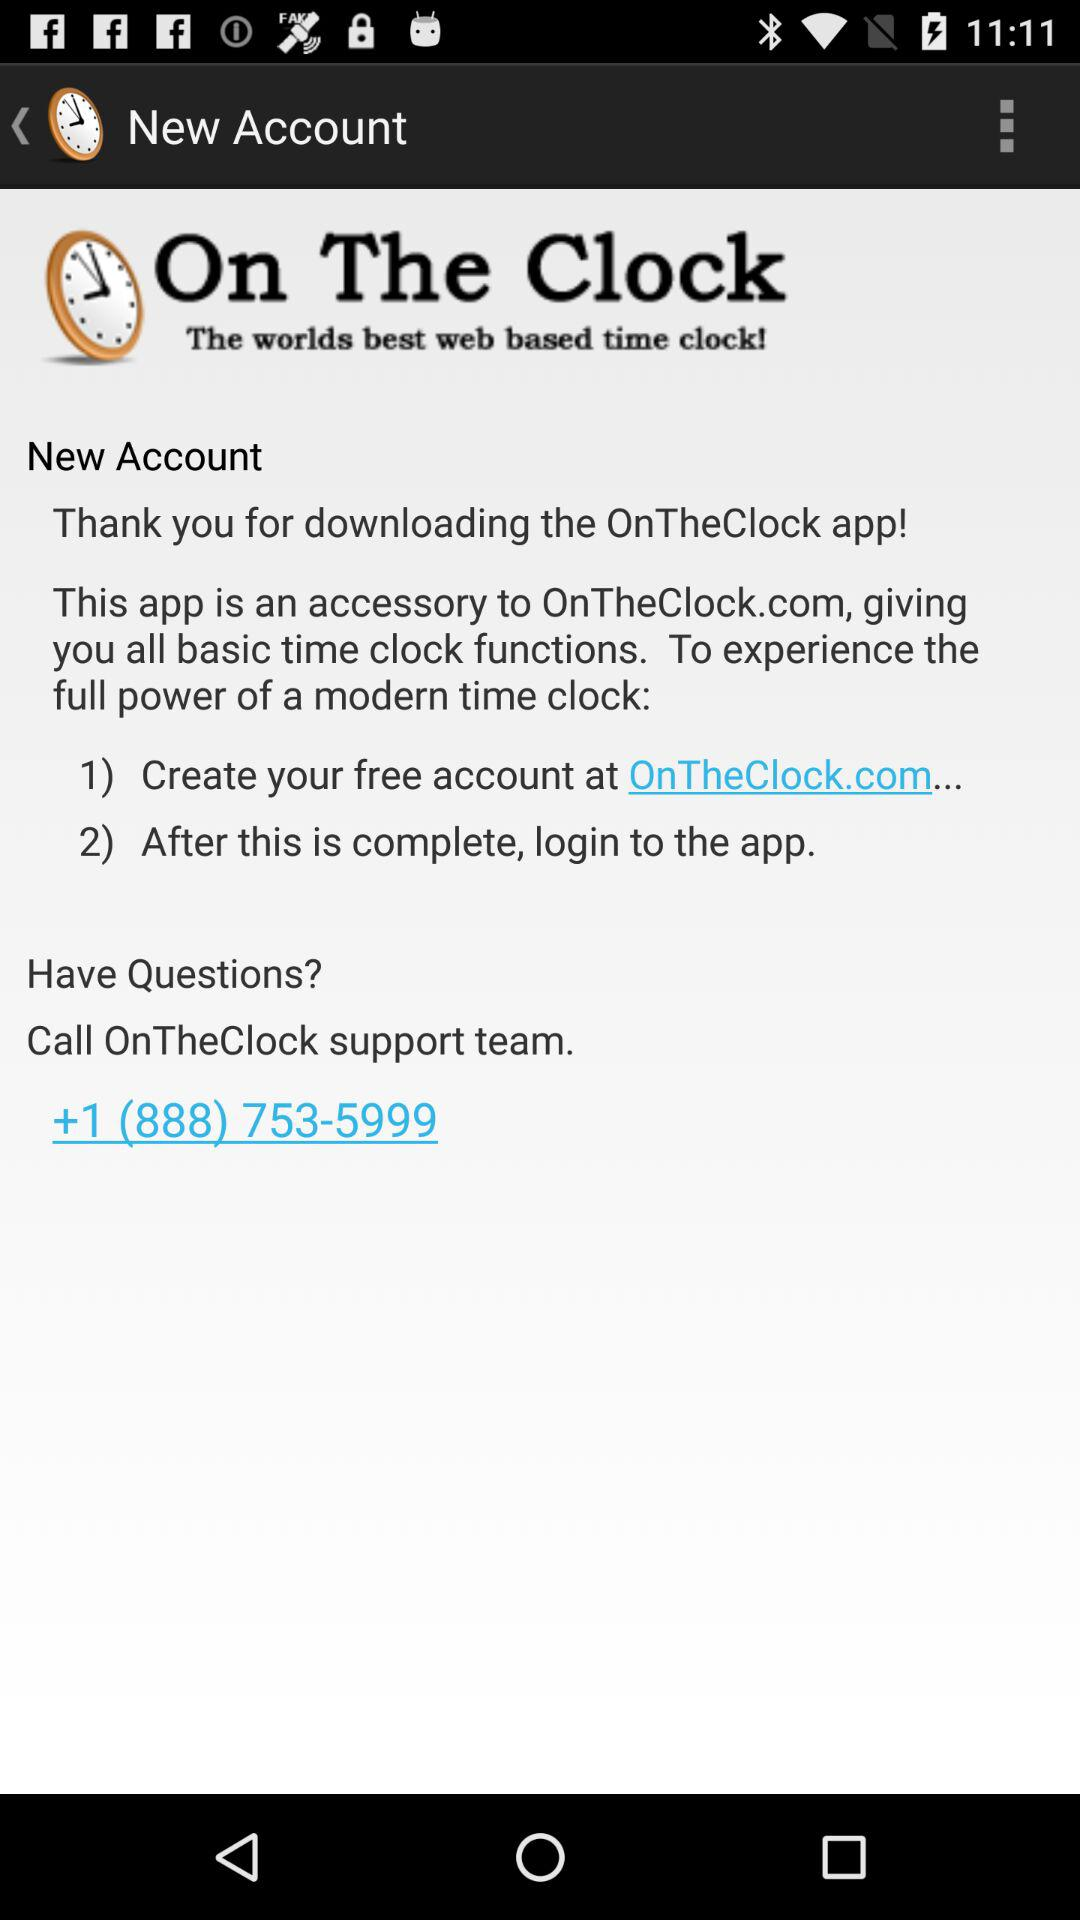What is the available link to create a new account? The available link to create a new account is "OnTheClock.com...". 